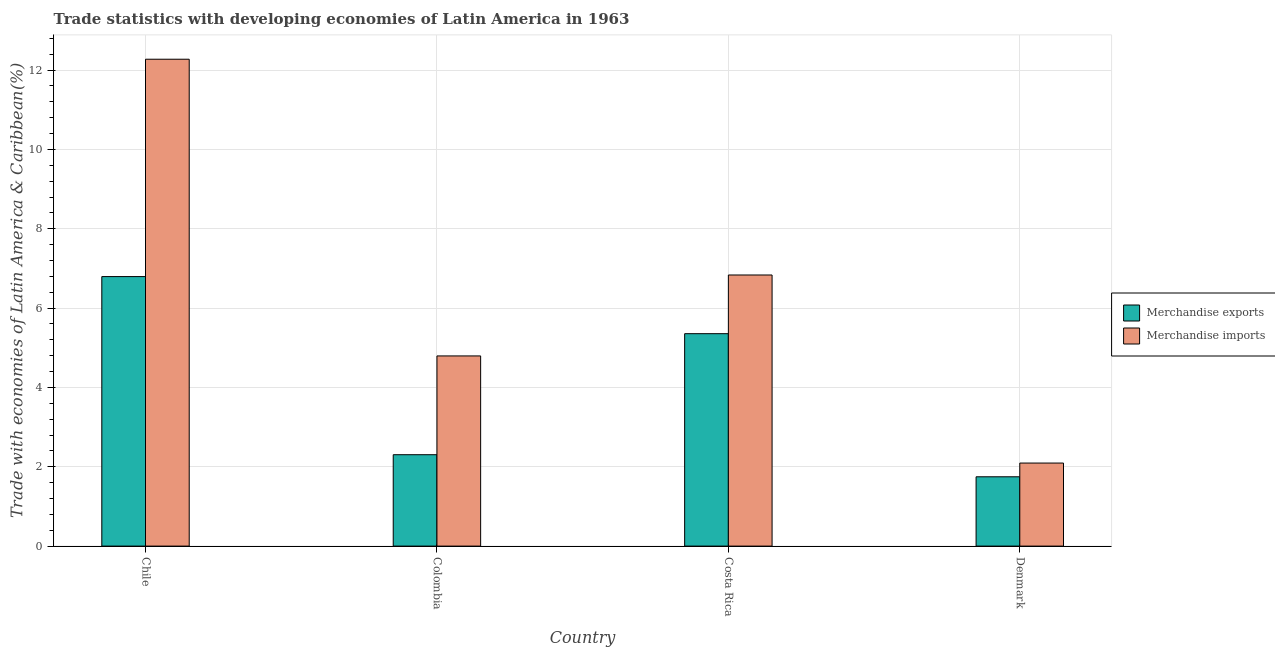Are the number of bars on each tick of the X-axis equal?
Keep it short and to the point. Yes. In how many cases, is the number of bars for a given country not equal to the number of legend labels?
Keep it short and to the point. 0. What is the merchandise imports in Denmark?
Your response must be concise. 2.09. Across all countries, what is the maximum merchandise imports?
Make the answer very short. 12.27. Across all countries, what is the minimum merchandise exports?
Keep it short and to the point. 1.75. In which country was the merchandise imports maximum?
Make the answer very short. Chile. In which country was the merchandise exports minimum?
Offer a very short reply. Denmark. What is the total merchandise imports in the graph?
Ensure brevity in your answer.  26. What is the difference between the merchandise exports in Chile and that in Costa Rica?
Make the answer very short. 1.44. What is the difference between the merchandise imports in Chile and the merchandise exports in Costa Rica?
Offer a very short reply. 6.92. What is the average merchandise exports per country?
Your answer should be very brief. 4.05. What is the difference between the merchandise imports and merchandise exports in Costa Rica?
Provide a succinct answer. 1.48. What is the ratio of the merchandise imports in Colombia to that in Costa Rica?
Make the answer very short. 0.7. Is the merchandise exports in Chile less than that in Costa Rica?
Provide a succinct answer. No. Is the difference between the merchandise exports in Costa Rica and Denmark greater than the difference between the merchandise imports in Costa Rica and Denmark?
Give a very brief answer. No. What is the difference between the highest and the second highest merchandise exports?
Your answer should be very brief. 1.44. What is the difference between the highest and the lowest merchandise imports?
Give a very brief answer. 10.18. In how many countries, is the merchandise exports greater than the average merchandise exports taken over all countries?
Your answer should be compact. 2. Is the sum of the merchandise imports in Chile and Denmark greater than the maximum merchandise exports across all countries?
Offer a terse response. Yes. What does the 2nd bar from the left in Costa Rica represents?
Provide a short and direct response. Merchandise imports. What does the 1st bar from the right in Chile represents?
Your response must be concise. Merchandise imports. Are the values on the major ticks of Y-axis written in scientific E-notation?
Your answer should be very brief. No. What is the title of the graph?
Make the answer very short. Trade statistics with developing economies of Latin America in 1963. What is the label or title of the Y-axis?
Keep it short and to the point. Trade with economies of Latin America & Caribbean(%). What is the Trade with economies of Latin America & Caribbean(%) in Merchandise exports in Chile?
Your answer should be very brief. 6.79. What is the Trade with economies of Latin America & Caribbean(%) in Merchandise imports in Chile?
Offer a very short reply. 12.27. What is the Trade with economies of Latin America & Caribbean(%) in Merchandise exports in Colombia?
Your response must be concise. 2.3. What is the Trade with economies of Latin America & Caribbean(%) in Merchandise imports in Colombia?
Provide a short and direct response. 4.79. What is the Trade with economies of Latin America & Caribbean(%) in Merchandise exports in Costa Rica?
Make the answer very short. 5.36. What is the Trade with economies of Latin America & Caribbean(%) of Merchandise imports in Costa Rica?
Ensure brevity in your answer.  6.83. What is the Trade with economies of Latin America & Caribbean(%) of Merchandise exports in Denmark?
Your answer should be very brief. 1.75. What is the Trade with economies of Latin America & Caribbean(%) in Merchandise imports in Denmark?
Your response must be concise. 2.09. Across all countries, what is the maximum Trade with economies of Latin America & Caribbean(%) of Merchandise exports?
Make the answer very short. 6.79. Across all countries, what is the maximum Trade with economies of Latin America & Caribbean(%) of Merchandise imports?
Provide a succinct answer. 12.27. Across all countries, what is the minimum Trade with economies of Latin America & Caribbean(%) of Merchandise exports?
Provide a short and direct response. 1.75. Across all countries, what is the minimum Trade with economies of Latin America & Caribbean(%) in Merchandise imports?
Provide a succinct answer. 2.09. What is the total Trade with economies of Latin America & Caribbean(%) in Merchandise exports in the graph?
Your answer should be compact. 16.2. What is the total Trade with economies of Latin America & Caribbean(%) in Merchandise imports in the graph?
Your answer should be compact. 26. What is the difference between the Trade with economies of Latin America & Caribbean(%) of Merchandise exports in Chile and that in Colombia?
Make the answer very short. 4.49. What is the difference between the Trade with economies of Latin America & Caribbean(%) of Merchandise imports in Chile and that in Colombia?
Your response must be concise. 7.48. What is the difference between the Trade with economies of Latin America & Caribbean(%) of Merchandise exports in Chile and that in Costa Rica?
Provide a short and direct response. 1.44. What is the difference between the Trade with economies of Latin America & Caribbean(%) of Merchandise imports in Chile and that in Costa Rica?
Offer a very short reply. 5.44. What is the difference between the Trade with economies of Latin America & Caribbean(%) of Merchandise exports in Chile and that in Denmark?
Provide a succinct answer. 5.05. What is the difference between the Trade with economies of Latin America & Caribbean(%) of Merchandise imports in Chile and that in Denmark?
Provide a succinct answer. 10.18. What is the difference between the Trade with economies of Latin America & Caribbean(%) in Merchandise exports in Colombia and that in Costa Rica?
Your answer should be very brief. -3.05. What is the difference between the Trade with economies of Latin America & Caribbean(%) in Merchandise imports in Colombia and that in Costa Rica?
Give a very brief answer. -2.04. What is the difference between the Trade with economies of Latin America & Caribbean(%) in Merchandise exports in Colombia and that in Denmark?
Ensure brevity in your answer.  0.56. What is the difference between the Trade with economies of Latin America & Caribbean(%) in Merchandise imports in Colombia and that in Denmark?
Your answer should be very brief. 2.7. What is the difference between the Trade with economies of Latin America & Caribbean(%) of Merchandise exports in Costa Rica and that in Denmark?
Provide a succinct answer. 3.61. What is the difference between the Trade with economies of Latin America & Caribbean(%) of Merchandise imports in Costa Rica and that in Denmark?
Ensure brevity in your answer.  4.74. What is the difference between the Trade with economies of Latin America & Caribbean(%) in Merchandise exports in Chile and the Trade with economies of Latin America & Caribbean(%) in Merchandise imports in Colombia?
Offer a terse response. 2. What is the difference between the Trade with economies of Latin America & Caribbean(%) of Merchandise exports in Chile and the Trade with economies of Latin America & Caribbean(%) of Merchandise imports in Costa Rica?
Your answer should be compact. -0.04. What is the difference between the Trade with economies of Latin America & Caribbean(%) in Merchandise exports in Chile and the Trade with economies of Latin America & Caribbean(%) in Merchandise imports in Denmark?
Make the answer very short. 4.7. What is the difference between the Trade with economies of Latin America & Caribbean(%) in Merchandise exports in Colombia and the Trade with economies of Latin America & Caribbean(%) in Merchandise imports in Costa Rica?
Your response must be concise. -4.53. What is the difference between the Trade with economies of Latin America & Caribbean(%) of Merchandise exports in Colombia and the Trade with economies of Latin America & Caribbean(%) of Merchandise imports in Denmark?
Provide a short and direct response. 0.21. What is the difference between the Trade with economies of Latin America & Caribbean(%) of Merchandise exports in Costa Rica and the Trade with economies of Latin America & Caribbean(%) of Merchandise imports in Denmark?
Your answer should be compact. 3.26. What is the average Trade with economies of Latin America & Caribbean(%) in Merchandise exports per country?
Your answer should be compact. 4.05. What is the average Trade with economies of Latin America & Caribbean(%) in Merchandise imports per country?
Make the answer very short. 6.5. What is the difference between the Trade with economies of Latin America & Caribbean(%) in Merchandise exports and Trade with economies of Latin America & Caribbean(%) in Merchandise imports in Chile?
Provide a short and direct response. -5.48. What is the difference between the Trade with economies of Latin America & Caribbean(%) of Merchandise exports and Trade with economies of Latin America & Caribbean(%) of Merchandise imports in Colombia?
Offer a terse response. -2.49. What is the difference between the Trade with economies of Latin America & Caribbean(%) in Merchandise exports and Trade with economies of Latin America & Caribbean(%) in Merchandise imports in Costa Rica?
Offer a terse response. -1.48. What is the difference between the Trade with economies of Latin America & Caribbean(%) of Merchandise exports and Trade with economies of Latin America & Caribbean(%) of Merchandise imports in Denmark?
Provide a succinct answer. -0.35. What is the ratio of the Trade with economies of Latin America & Caribbean(%) of Merchandise exports in Chile to that in Colombia?
Provide a short and direct response. 2.95. What is the ratio of the Trade with economies of Latin America & Caribbean(%) in Merchandise imports in Chile to that in Colombia?
Keep it short and to the point. 2.56. What is the ratio of the Trade with economies of Latin America & Caribbean(%) in Merchandise exports in Chile to that in Costa Rica?
Offer a terse response. 1.27. What is the ratio of the Trade with economies of Latin America & Caribbean(%) of Merchandise imports in Chile to that in Costa Rica?
Keep it short and to the point. 1.8. What is the ratio of the Trade with economies of Latin America & Caribbean(%) in Merchandise exports in Chile to that in Denmark?
Give a very brief answer. 3.89. What is the ratio of the Trade with economies of Latin America & Caribbean(%) of Merchandise imports in Chile to that in Denmark?
Make the answer very short. 5.86. What is the ratio of the Trade with economies of Latin America & Caribbean(%) in Merchandise exports in Colombia to that in Costa Rica?
Give a very brief answer. 0.43. What is the ratio of the Trade with economies of Latin America & Caribbean(%) in Merchandise imports in Colombia to that in Costa Rica?
Ensure brevity in your answer.  0.7. What is the ratio of the Trade with economies of Latin America & Caribbean(%) in Merchandise exports in Colombia to that in Denmark?
Provide a succinct answer. 1.32. What is the ratio of the Trade with economies of Latin America & Caribbean(%) in Merchandise imports in Colombia to that in Denmark?
Give a very brief answer. 2.29. What is the ratio of the Trade with economies of Latin America & Caribbean(%) of Merchandise exports in Costa Rica to that in Denmark?
Provide a succinct answer. 3.06. What is the ratio of the Trade with economies of Latin America & Caribbean(%) in Merchandise imports in Costa Rica to that in Denmark?
Offer a terse response. 3.26. What is the difference between the highest and the second highest Trade with economies of Latin America & Caribbean(%) in Merchandise exports?
Ensure brevity in your answer.  1.44. What is the difference between the highest and the second highest Trade with economies of Latin America & Caribbean(%) of Merchandise imports?
Your response must be concise. 5.44. What is the difference between the highest and the lowest Trade with economies of Latin America & Caribbean(%) of Merchandise exports?
Keep it short and to the point. 5.05. What is the difference between the highest and the lowest Trade with economies of Latin America & Caribbean(%) of Merchandise imports?
Your response must be concise. 10.18. 